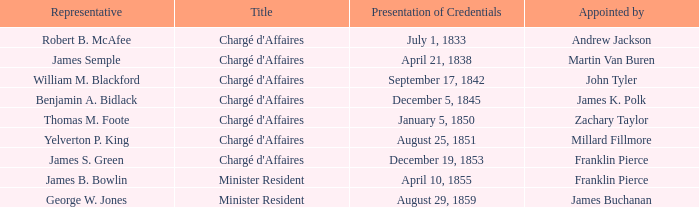What title has a cessation of mission for august 13, 1854? Chargé d'Affaires. 